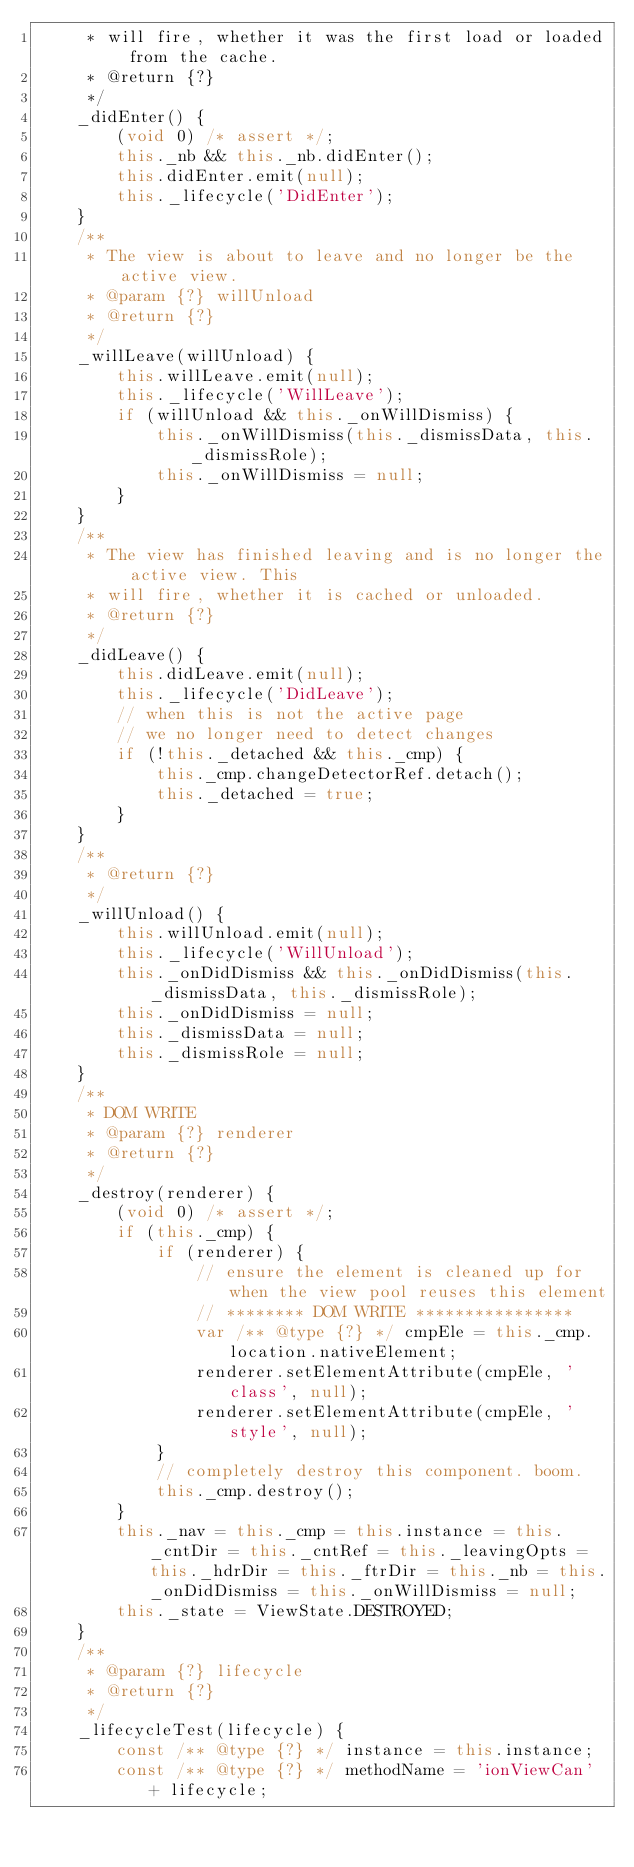Convert code to text. <code><loc_0><loc_0><loc_500><loc_500><_JavaScript_>     * will fire, whether it was the first load or loaded from the cache.
     * @return {?}
     */
    _didEnter() {
        (void 0) /* assert */;
        this._nb && this._nb.didEnter();
        this.didEnter.emit(null);
        this._lifecycle('DidEnter');
    }
    /**
     * The view is about to leave and no longer be the active view.
     * @param {?} willUnload
     * @return {?}
     */
    _willLeave(willUnload) {
        this.willLeave.emit(null);
        this._lifecycle('WillLeave');
        if (willUnload && this._onWillDismiss) {
            this._onWillDismiss(this._dismissData, this._dismissRole);
            this._onWillDismiss = null;
        }
    }
    /**
     * The view has finished leaving and is no longer the active view. This
     * will fire, whether it is cached or unloaded.
     * @return {?}
     */
    _didLeave() {
        this.didLeave.emit(null);
        this._lifecycle('DidLeave');
        // when this is not the active page
        // we no longer need to detect changes
        if (!this._detached && this._cmp) {
            this._cmp.changeDetectorRef.detach();
            this._detached = true;
        }
    }
    /**
     * @return {?}
     */
    _willUnload() {
        this.willUnload.emit(null);
        this._lifecycle('WillUnload');
        this._onDidDismiss && this._onDidDismiss(this._dismissData, this._dismissRole);
        this._onDidDismiss = null;
        this._dismissData = null;
        this._dismissRole = null;
    }
    /**
     * DOM WRITE
     * @param {?} renderer
     * @return {?}
     */
    _destroy(renderer) {
        (void 0) /* assert */;
        if (this._cmp) {
            if (renderer) {
                // ensure the element is cleaned up for when the view pool reuses this element
                // ******** DOM WRITE ****************
                var /** @type {?} */ cmpEle = this._cmp.location.nativeElement;
                renderer.setElementAttribute(cmpEle, 'class', null);
                renderer.setElementAttribute(cmpEle, 'style', null);
            }
            // completely destroy this component. boom.
            this._cmp.destroy();
        }
        this._nav = this._cmp = this.instance = this._cntDir = this._cntRef = this._leavingOpts = this._hdrDir = this._ftrDir = this._nb = this._onDidDismiss = this._onWillDismiss = null;
        this._state = ViewState.DESTROYED;
    }
    /**
     * @param {?} lifecycle
     * @return {?}
     */
    _lifecycleTest(lifecycle) {
        const /** @type {?} */ instance = this.instance;
        const /** @type {?} */ methodName = 'ionViewCan' + lifecycle;</code> 